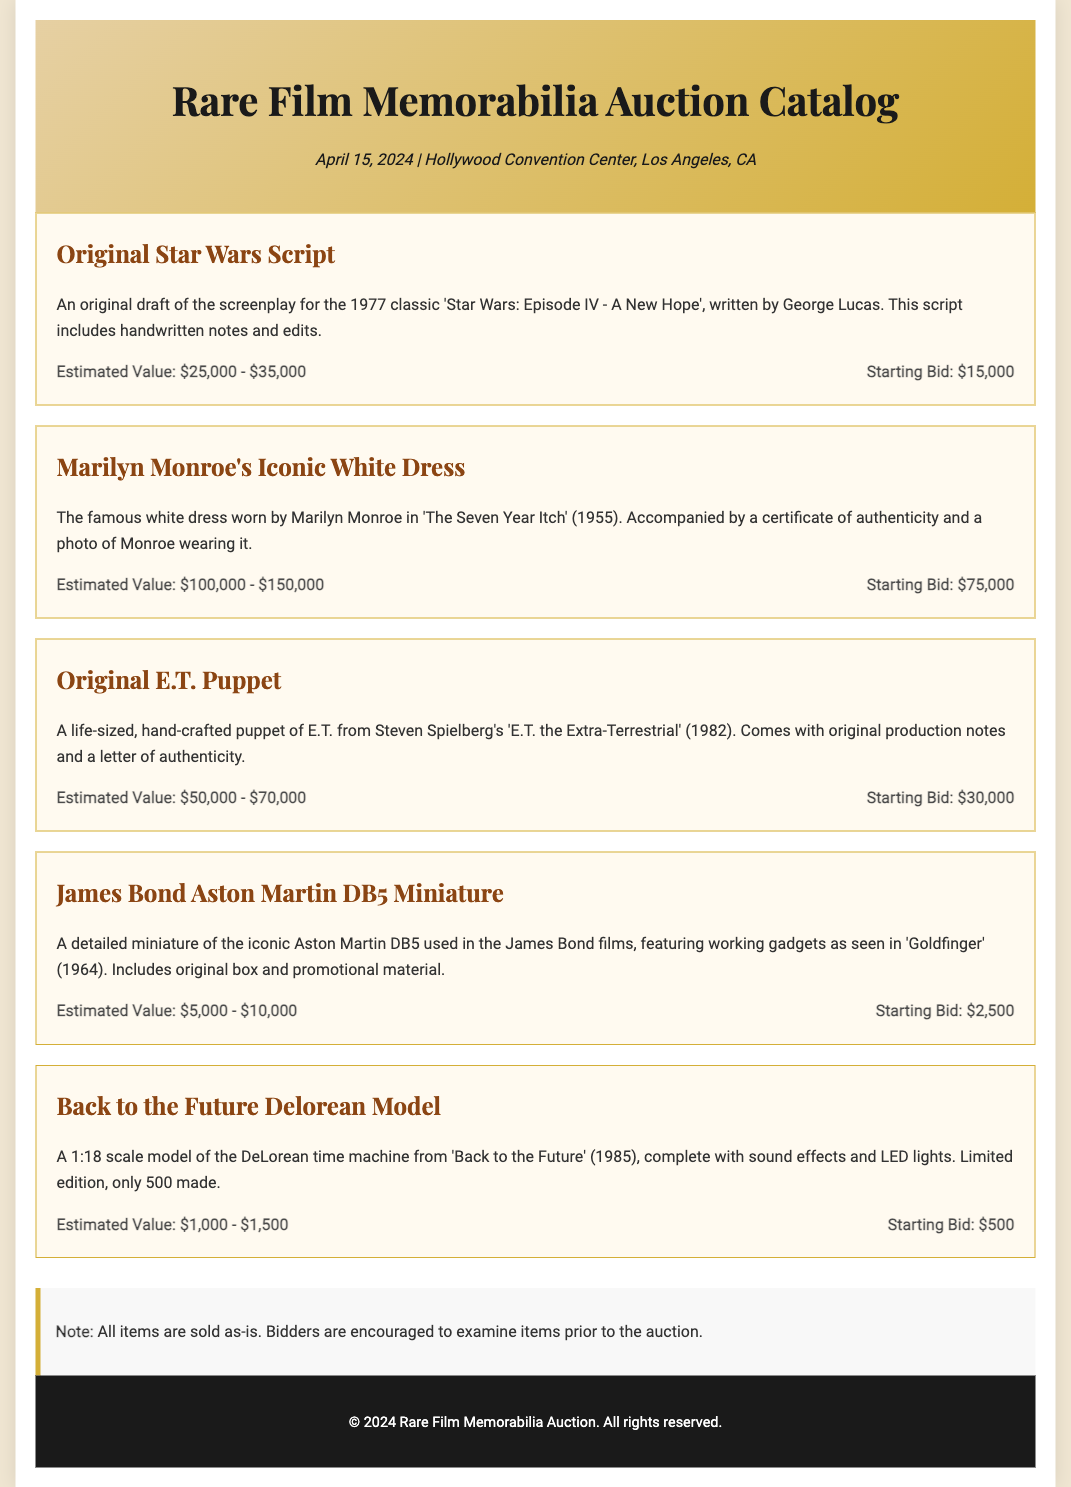What is the date of the auction? The date of the auction is specified at the top of the document under event details.
Answer: April 15, 2024 What is the starting bid for Marilyn Monroe's Iconic White Dress? The starting bid for this item is listed in the details of the item.
Answer: $75,000 What is the estimated value range of the Original E.T. Puppet? The estimated value is noted in the item description for the Original E.T. Puppet.
Answer: $50,000 - $70,000 How many Back to the Future Delorean Models were made? This information is provided in the description of the Back to the Future Delorean Model item.
Answer: 500 What type of document is this? This document is focused on showcasing items for auction and displaying their details, fitting a specific type usually used for events.
Answer: Auction Catalog What script is featured in the auction? The auction catalog lists various items, and one of them is the original script for a well-known film.
Answer: Star Wars Script What is the name of the convention center hosting the auction? The convention center for the auction is mentioned in the event details section.
Answer: Hollywood Convention Center What theme does this auction focus on? The primary focus of the auction is stated in the title and can be inferred from the items presented.
Answer: Film Memorabilia 